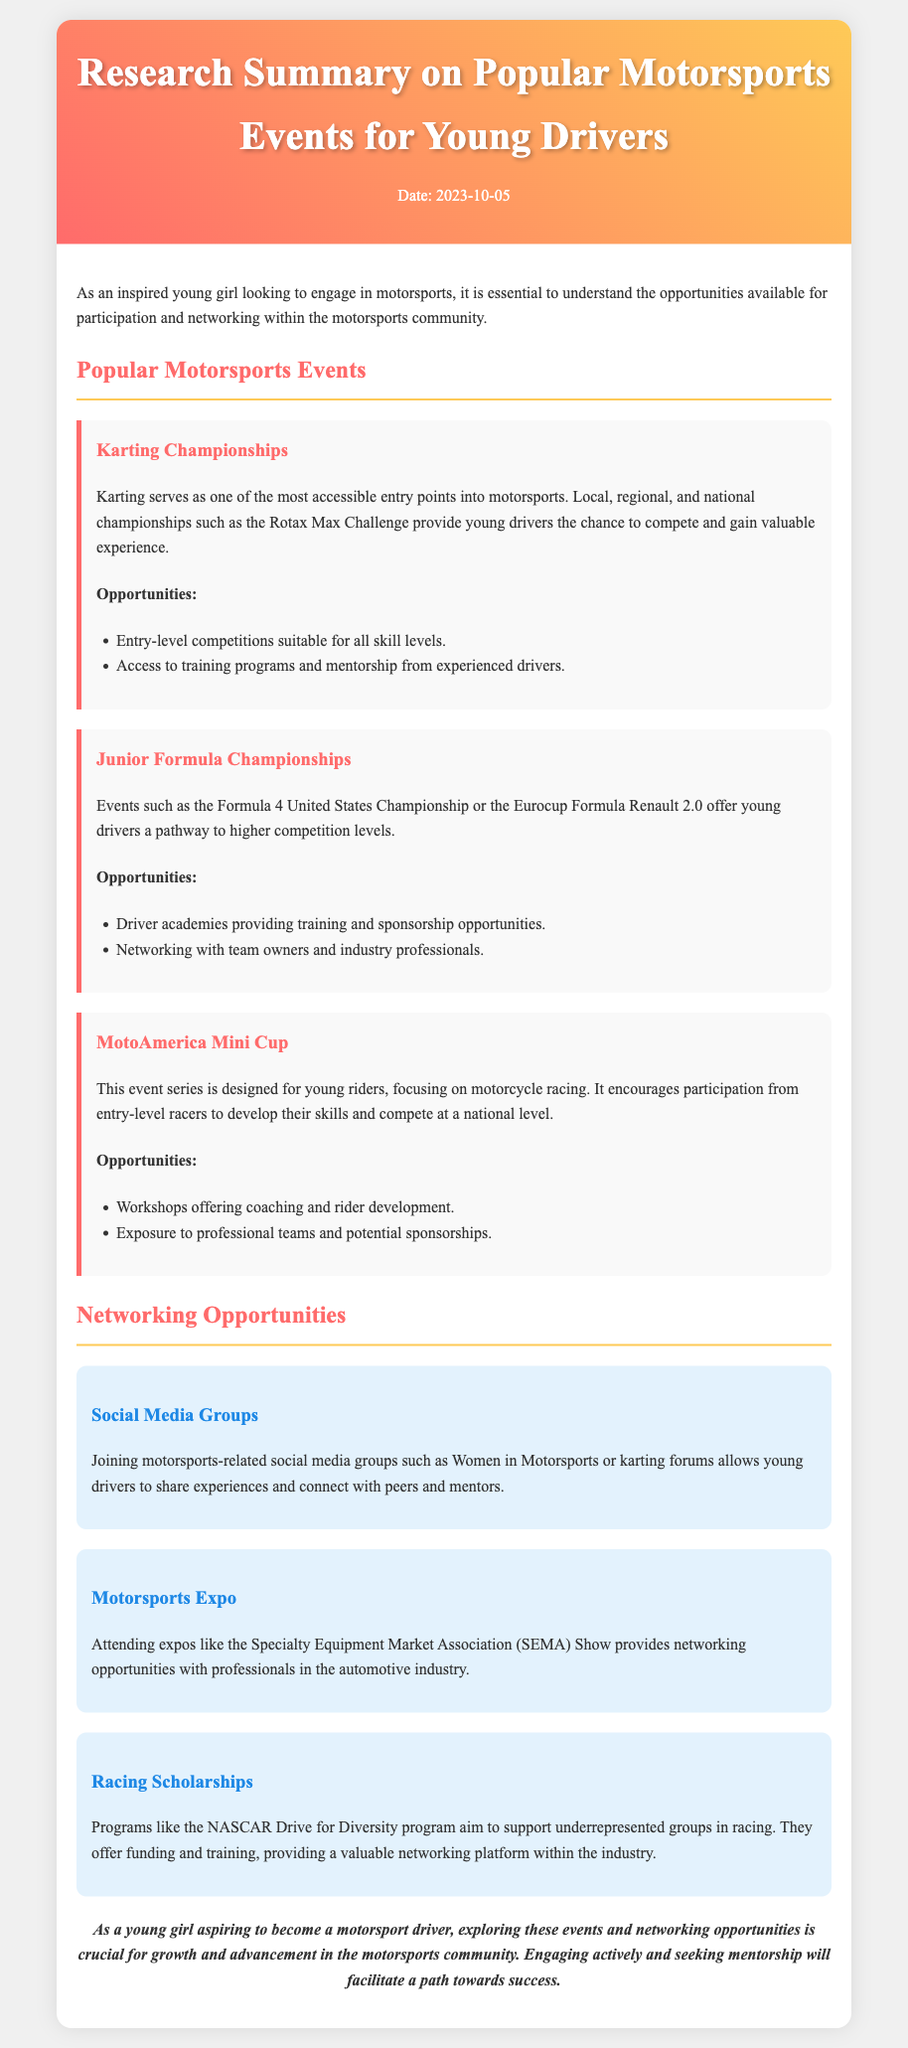what is the date of the memo? The date of the memo is mentioned at the top of the document in the header section.
Answer: 2023-10-05 what is the title of the first event listed? The title of the first event is the first heading under the Popular Motorsports Events section.
Answer: Karting Championships what kind of opportunities are provided by Junior Formula Championships? The opportunities are listed in a bullet point format under the event description.
Answer: Driver academies providing training and sponsorship opportunities what is the main focus of the MotoAmerica Mini Cup? The main focus is described in the introductory sentence of the event's section.
Answer: motorcycle racing name one social media group mentioned for networking. The social media groups are detailed in the Networking Opportunities section.
Answer: Women in Motorsports how do Racing Scholarships support underrepresented groups? The document explains the purpose of the program in the Networking Opportunities section.
Answer: funding and training what types of competitions does Karting offer? The types of competitions are described in the opportunities section under Karting Championships.
Answer: entry-level competitions suitable for all skill levels name one expo that provides networking opportunities. The networking section lists specific expos that are relevant for networking.
Answer: SEMA Show what is one benefit of attending the Specialty Equipment Market Association? The benefit is highlighted in the explanation of the expo under Networking Opportunities.
Answer: networking opportunities with professionals in the automotive industry 